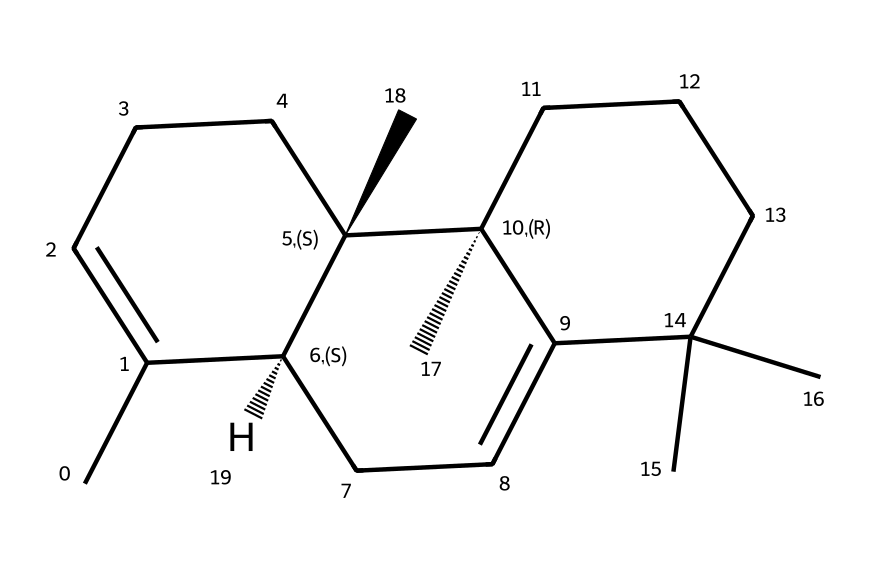What is the molecular formula of beta-caryophyllene? By analyzing the SMILES representation, we can count the number of carbon (C) and hydrogen (H) atoms. The structure has 15 carbon atoms and 24 hydrogen atoms, leading to the molecular formula C15H24.
Answer: C15H24 How many cyclic structures are present in beta-caryophyllene? In the given SMILES, we can see indications of ring structures through the use of numbers. There are two numbers "1", "2", and "3", indicating three cycles in the structure, confirming that beta-caryophyllene has three cyclic structures.
Answer: three What type of bonds connect the atoms in beta-caryophyllene? The analysis of the SMILES shows various symbols; carbon atoms are predominantly connected by single bonds (implicitly shown) and some double bonds (shown explicitly by "="). Therefore, the predominant bond types are single and double bonds.
Answer: single and double Which part of beta-caryophyllene is responsible for its anti-inflammatory properties? Beta-caryophyllene contains specific functional groups and structure features, including a bicyclic system. The unique structure leads to binding with cannabinoid receptors which is believed to contribute to its anti-inflammatory properties.
Answer: bicyclic system What is the significance of the chiral centers in beta-caryophyllene? The SMILES shows chiral centers indicated by the "@" symbols. These chiral centers signify that beta-caryophyllene can exist in different stereoisomeric forms, which can lead to variations in biological activity and therapeutic effects on inflammation and pain management.
Answer: stereoisomeric forms 